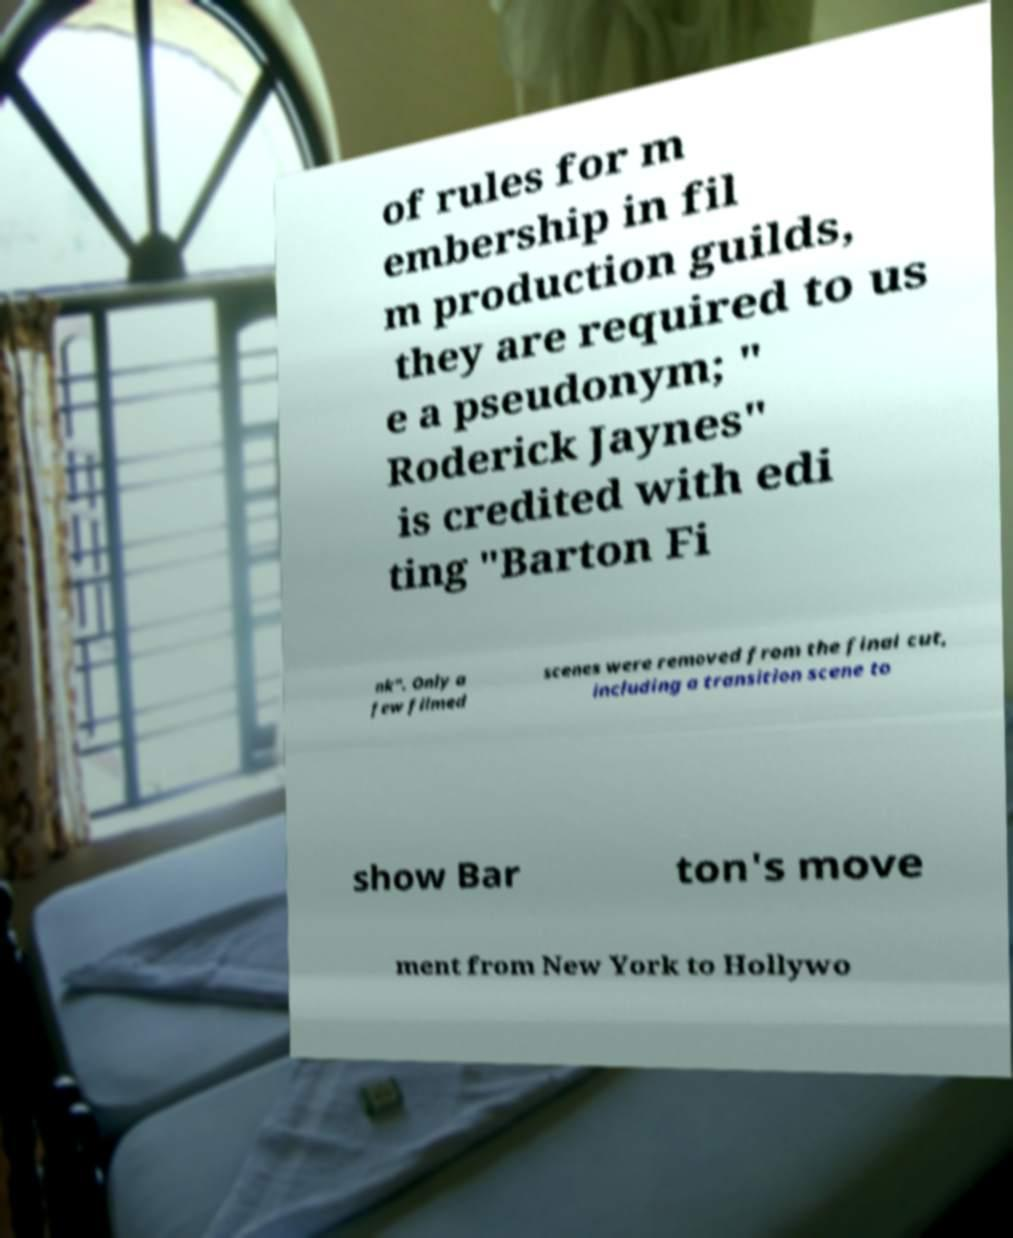What messages or text are displayed in this image? I need them in a readable, typed format. of rules for m embership in fil m production guilds, they are required to us e a pseudonym; " Roderick Jaynes" is credited with edi ting "Barton Fi nk". Only a few filmed scenes were removed from the final cut, including a transition scene to show Bar ton's move ment from New York to Hollywo 